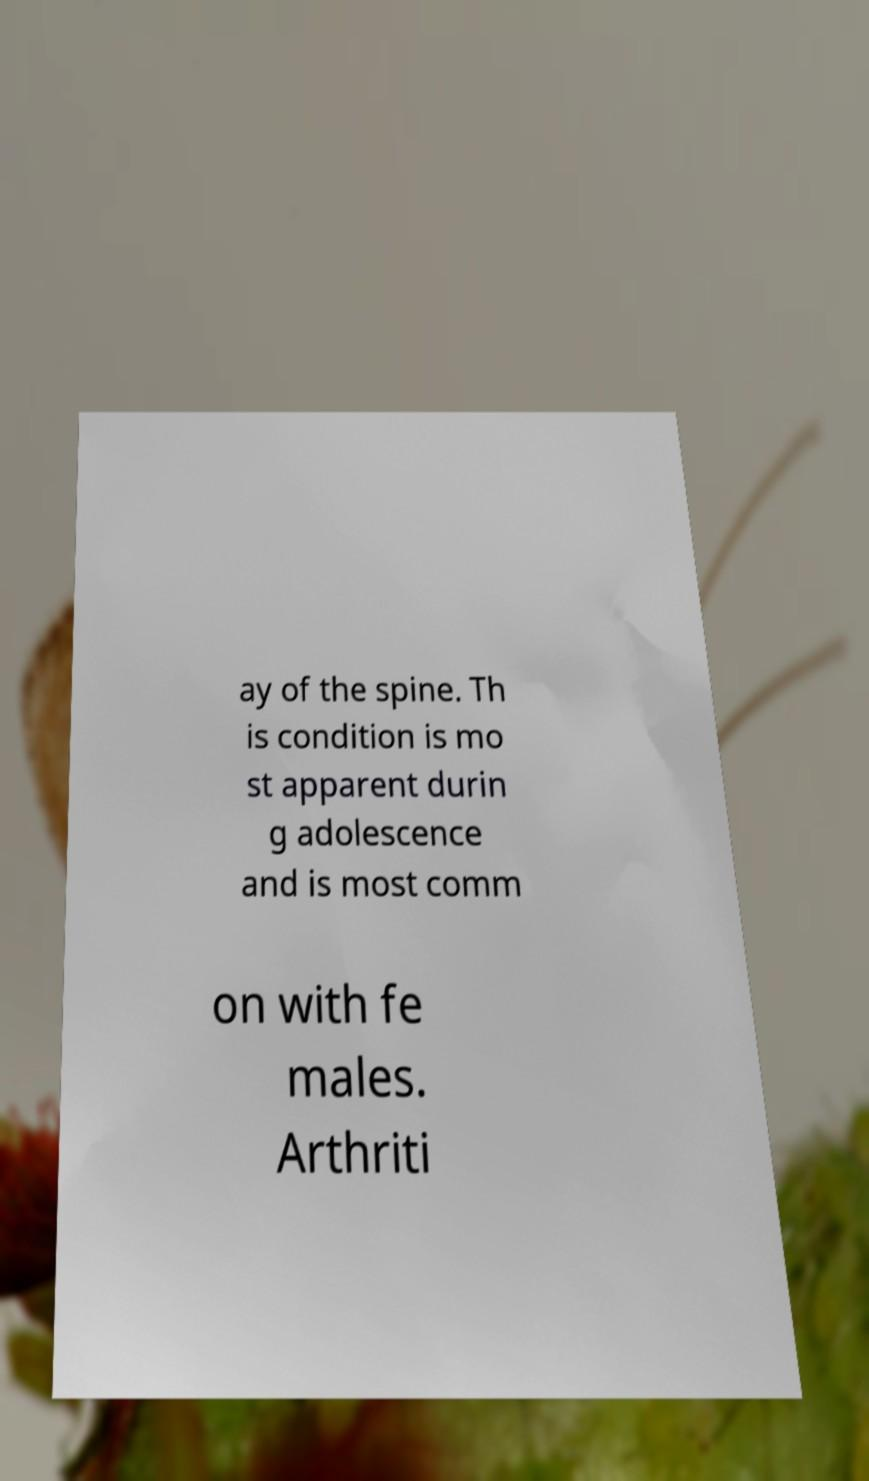For documentation purposes, I need the text within this image transcribed. Could you provide that? ay of the spine. Th is condition is mo st apparent durin g adolescence and is most comm on with fe males. Arthriti 